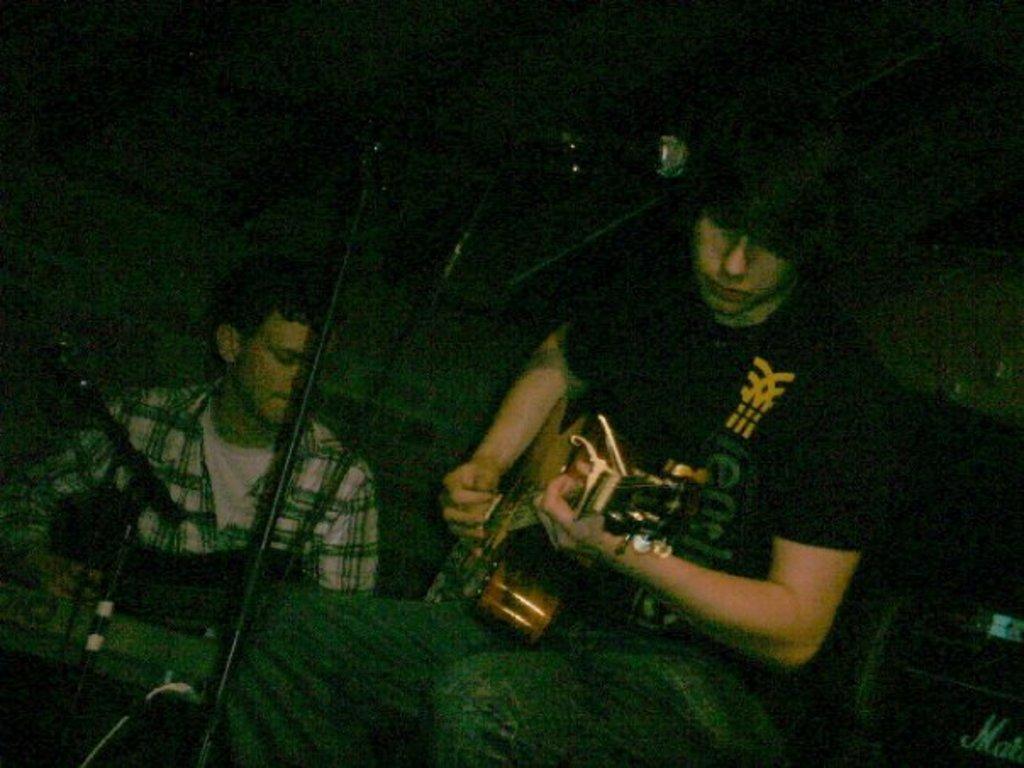Please provide a concise description of this image. In this image there are two persons playing musical instruments. 